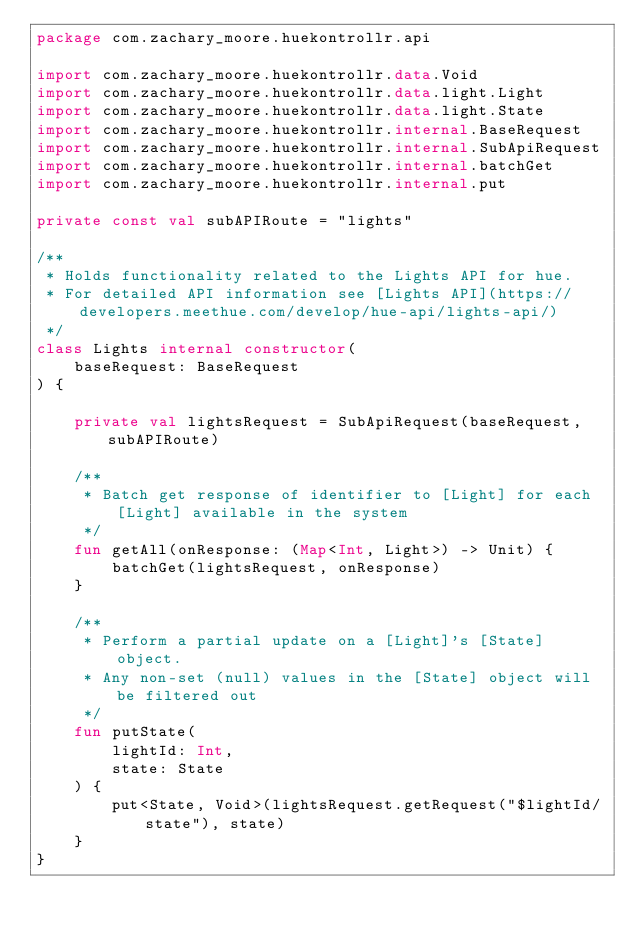Convert code to text. <code><loc_0><loc_0><loc_500><loc_500><_Kotlin_>package com.zachary_moore.huekontrollr.api

import com.zachary_moore.huekontrollr.data.Void
import com.zachary_moore.huekontrollr.data.light.Light
import com.zachary_moore.huekontrollr.data.light.State
import com.zachary_moore.huekontrollr.internal.BaseRequest
import com.zachary_moore.huekontrollr.internal.SubApiRequest
import com.zachary_moore.huekontrollr.internal.batchGet
import com.zachary_moore.huekontrollr.internal.put

private const val subAPIRoute = "lights"

/**
 * Holds functionality related to the Lights API for hue.
 * For detailed API information see [Lights API](https://developers.meethue.com/develop/hue-api/lights-api/)
 */
class Lights internal constructor(
    baseRequest: BaseRequest
) {

    private val lightsRequest = SubApiRequest(baseRequest, subAPIRoute)

    /**
     * Batch get response of identifier to [Light] for each [Light] available in the system
     */
    fun getAll(onResponse: (Map<Int, Light>) -> Unit) {
        batchGet(lightsRequest, onResponse)
    }

    /**
     * Perform a partial update on a [Light]'s [State] object.
     * Any non-set (null) values in the [State] object will be filtered out
     */
    fun putState(
        lightId: Int,
        state: State
    ) {
        put<State, Void>(lightsRequest.getRequest("$lightId/state"), state)
    }
}</code> 